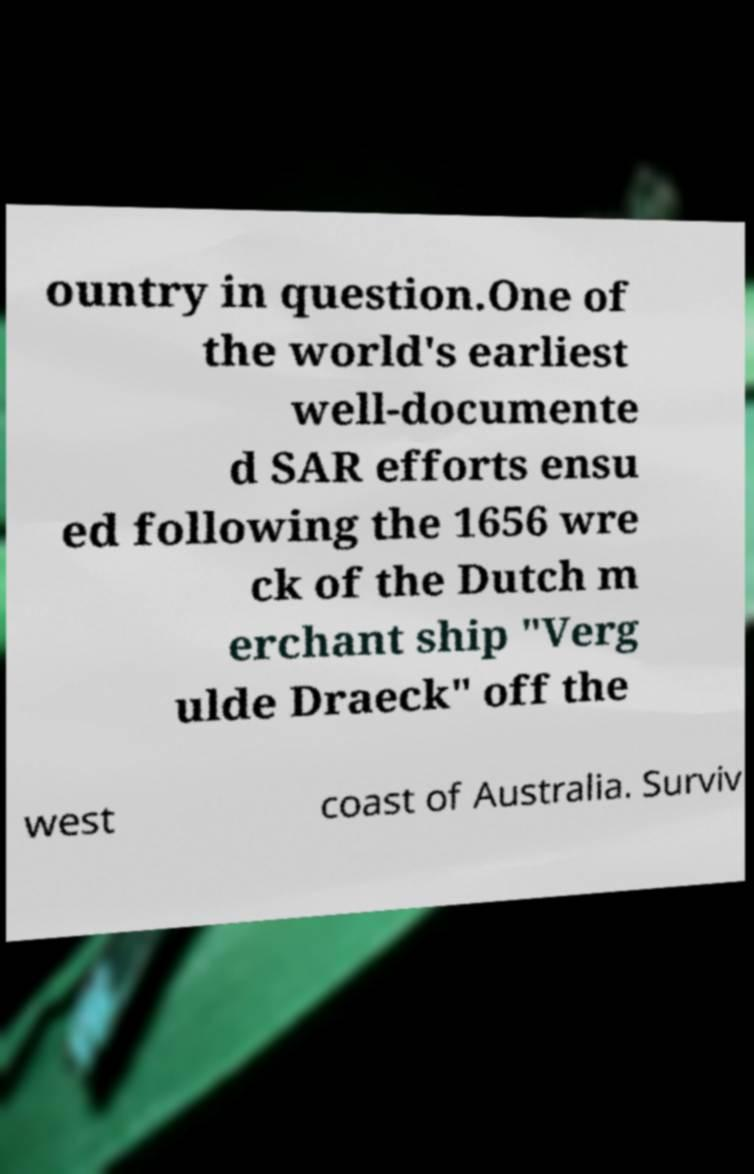Could you assist in decoding the text presented in this image and type it out clearly? ountry in question.One of the world's earliest well-documente d SAR efforts ensu ed following the 1656 wre ck of the Dutch m erchant ship "Verg ulde Draeck" off the west coast of Australia. Surviv 